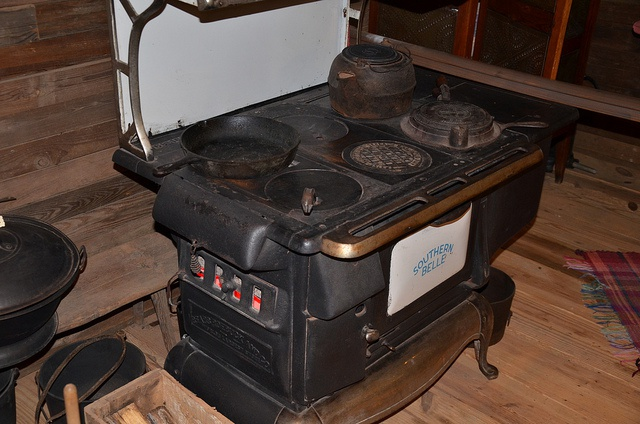Describe the objects in this image and their specific colors. I can see oven in maroon, black, gray, and darkgray tones and bench in maroon, gray, and black tones in this image. 